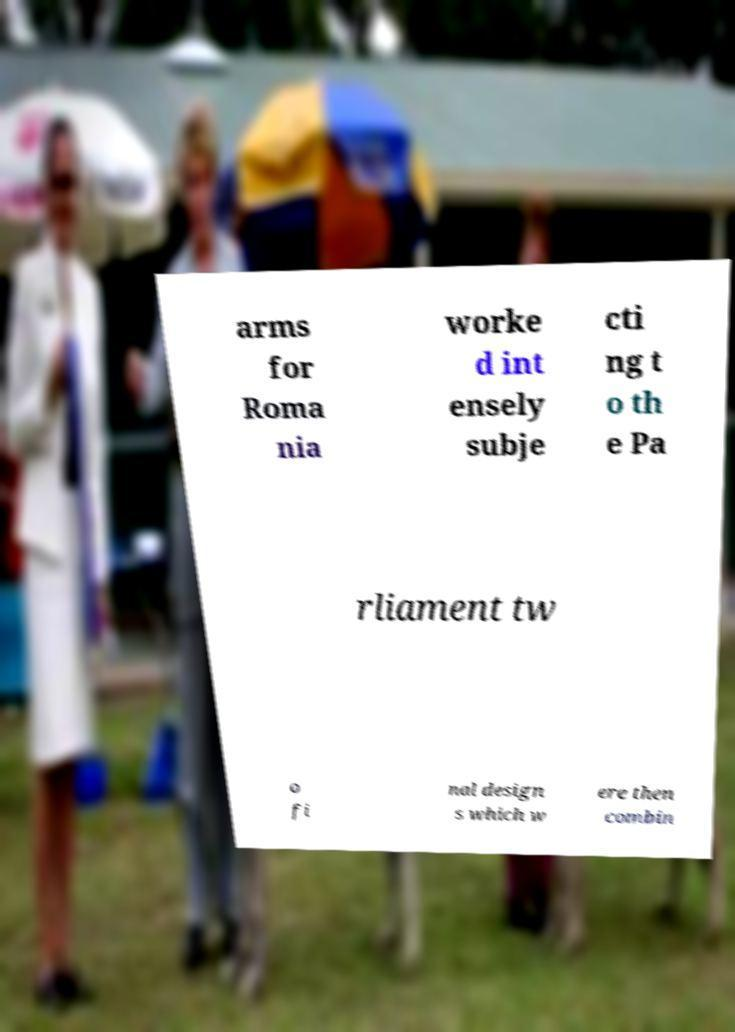Could you assist in decoding the text presented in this image and type it out clearly? arms for Roma nia worke d int ensely subje cti ng t o th e Pa rliament tw o fi nal design s which w ere then combin 